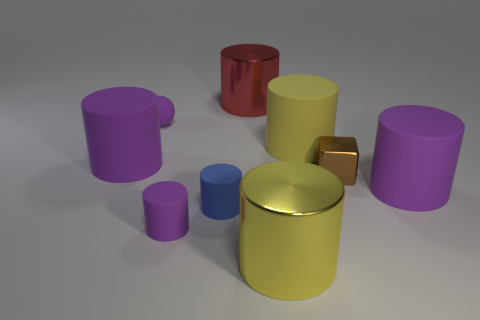Subtract all red spheres. How many purple cylinders are left? 3 Subtract all tiny purple cylinders. How many cylinders are left? 6 Subtract all red cylinders. How many cylinders are left? 6 Subtract all brown cylinders. Subtract all cyan spheres. How many cylinders are left? 7 Add 1 small gray metallic things. How many objects exist? 10 Subtract all cylinders. How many objects are left? 2 Subtract all brown blocks. Subtract all large rubber cylinders. How many objects are left? 5 Add 2 purple rubber cylinders. How many purple rubber cylinders are left? 5 Add 1 small brown cubes. How many small brown cubes exist? 2 Subtract 0 cyan cylinders. How many objects are left? 9 